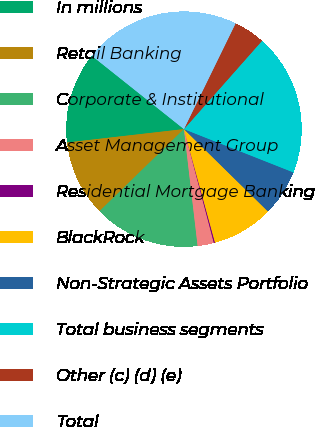Convert chart. <chart><loc_0><loc_0><loc_500><loc_500><pie_chart><fcel>In millions<fcel>Retail Banking<fcel>Corporate & Institutional<fcel>Asset Management Group<fcel>Residential Mortgage Banking<fcel>BlackRock<fcel>Non-Strategic Assets Portfolio<fcel>Total business segments<fcel>Other (c) (d) (e)<fcel>Total<nl><fcel>12.52%<fcel>10.46%<fcel>14.58%<fcel>2.23%<fcel>0.17%<fcel>8.4%<fcel>6.35%<fcel>19.47%<fcel>4.29%<fcel>21.53%<nl></chart> 